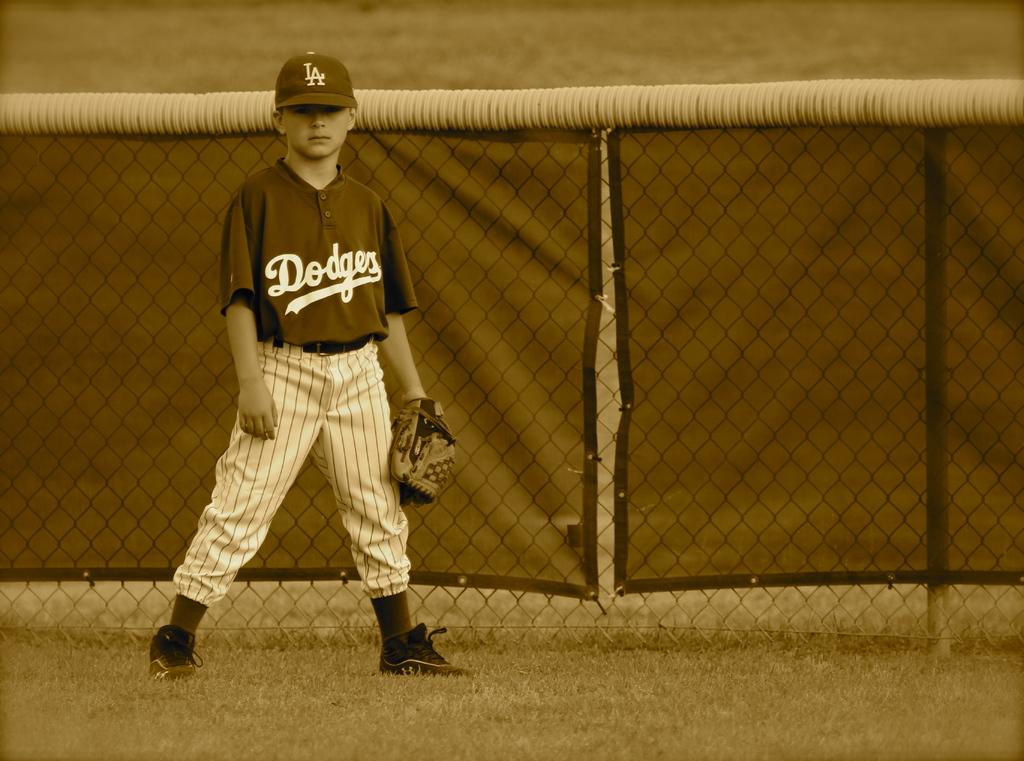What baseball team is the boy on?
Your response must be concise. Dodgers. Which team boy?
Give a very brief answer. Dodgers. 